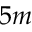Convert formula to latex. <formula><loc_0><loc_0><loc_500><loc_500>5 m</formula> 